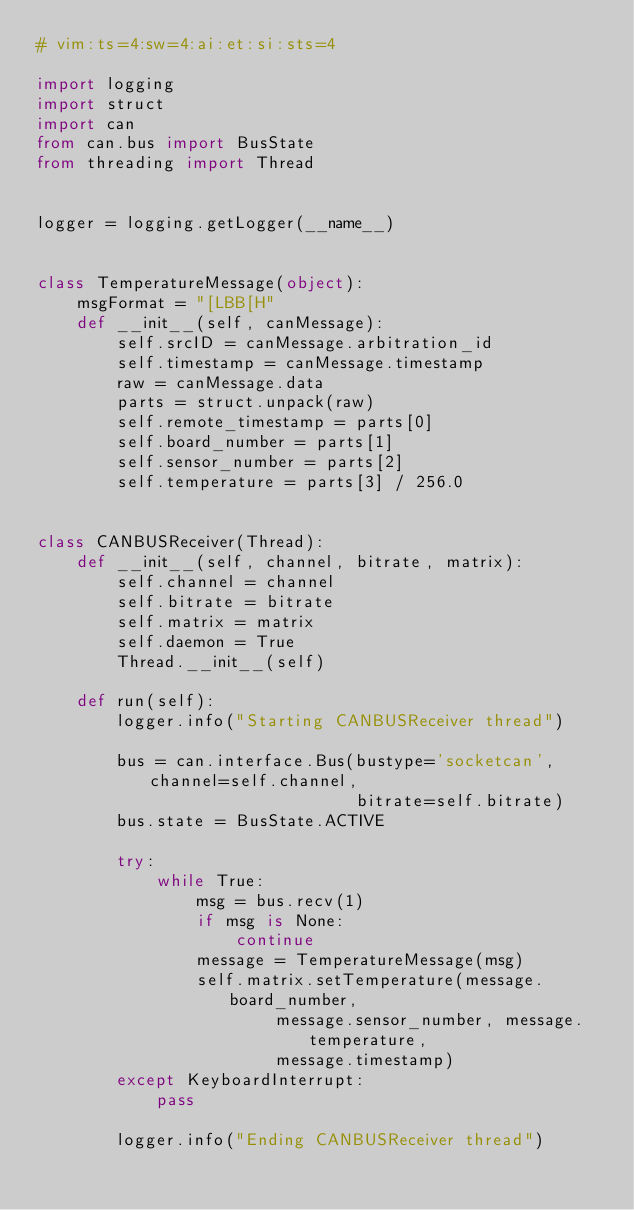<code> <loc_0><loc_0><loc_500><loc_500><_Python_># vim:ts=4:sw=4:ai:et:si:sts=4

import logging
import struct
import can
from can.bus import BusState
from threading import Thread


logger = logging.getLogger(__name__)


class TemperatureMessage(object):
    msgFormat = "[LBB[H"
    def __init__(self, canMessage):
        self.srcID = canMessage.arbitration_id
        self.timestamp = canMessage.timestamp
        raw = canMessage.data
        parts = struct.unpack(raw)
        self.remote_timestamp = parts[0]
        self.board_number = parts[1]
        self.sensor_number = parts[2]
        self.temperature = parts[3] / 256.0


class CANBUSReceiver(Thread):
    def __init__(self, channel, bitrate, matrix):
        self.channel = channel
        self.bitrate = bitrate
        self.matrix = matrix
        self.daemon = True
        Thread.__init__(self)

    def run(self):
        logger.info("Starting CANBUSReceiver thread")

        bus = can.interface.Bus(bustype='socketcan', channel=self.channel,
                                bitrate=self.bitrate)
        bus.state = BusState.ACTIVE

        try:
            while True:
                msg = bus.recv(1)
                if msg is None:
                    continue
                message = TemperatureMessage(msg)
                self.matrix.setTemperature(message.board_number,
                        message.sensor_number, message.temperature,
                        message.timestamp)
        except KeyboardInterrupt:
            pass

        logger.info("Ending CANBUSReceiver thread")
</code> 